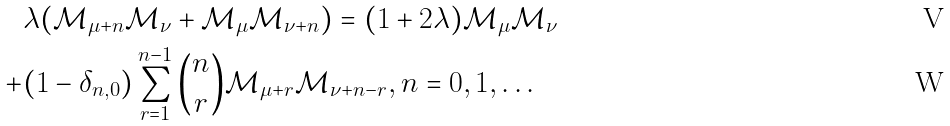<formula> <loc_0><loc_0><loc_500><loc_500>& \lambda ( { \mathcal { M } } _ { \mu + n } { \mathcal { M } } _ { \nu } + { \mathcal { M } } _ { \mu } { \mathcal { M } } _ { \nu + n } ) = ( 1 + 2 \lambda ) { \mathcal { M } } _ { \mu } { \mathcal { M } } _ { \nu } \\ + & ( 1 - \delta _ { n , 0 } ) \sum _ { r = 1 } ^ { n - 1 } { n \choose r } { \mathcal { M } } _ { \mu + r } { \mathcal { M } } _ { \nu + n - r } , n = 0 , 1 , \dots</formula> 